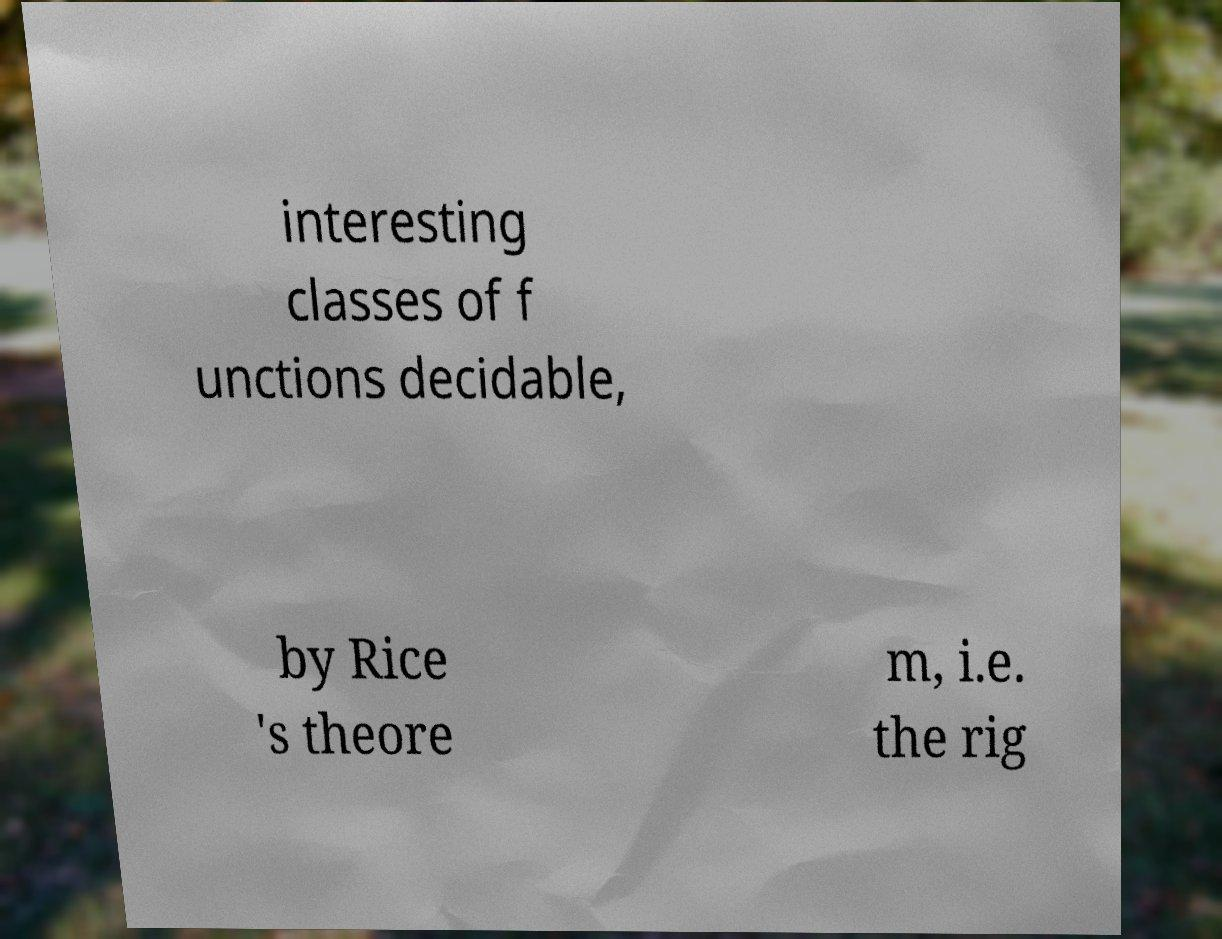Can you accurately transcribe the text from the provided image for me? interesting classes of f unctions decidable, by Rice 's theore m, i.e. the rig 